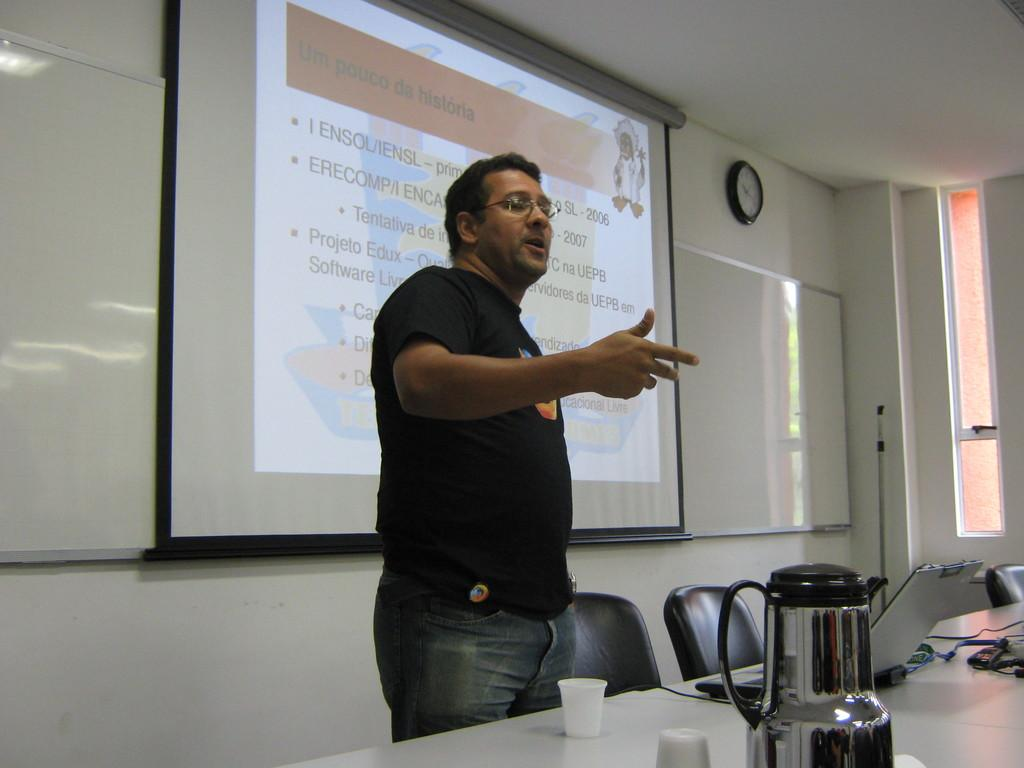<image>
Describe the image concisely. A man stands in front of a room with a projected slide labeled Un Pouco da historia. 